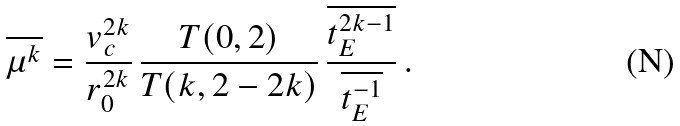<formula> <loc_0><loc_0><loc_500><loc_500>\overline { \mu ^ { k } } = \frac { v _ { c } ^ { 2 k } } { r _ { 0 } ^ { 2 k } } \, \frac { T ( 0 , 2 ) } { T ( k , 2 - 2 k ) } \, \frac { \overline { t _ { E } ^ { 2 k - 1 } } } { \overline { t _ { E } ^ { - 1 } } } \, .</formula> 